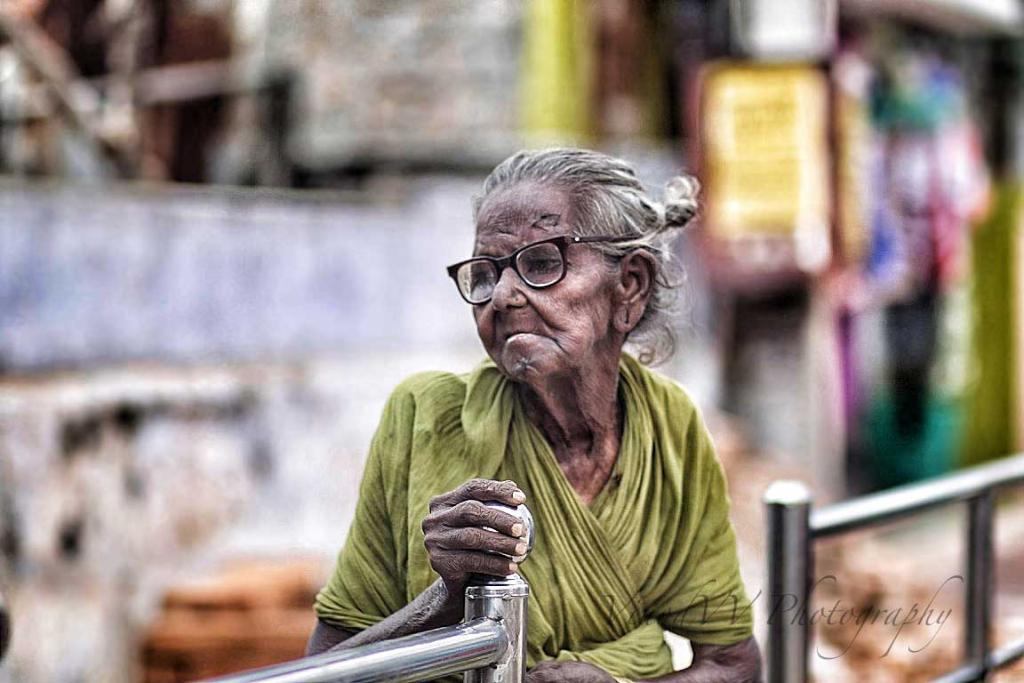Who is present in the image? There is a woman in the image. What is the woman doing in the image? The woman is standing on the ground and holding barrier poles. What type of pet is the woman holding in the image? There is no pet present in the image; the woman is holding barrier poles. How does the woman's stomach feel in the image? There is no information about the woman's stomach in the image, so it cannot be determined how she feels. 